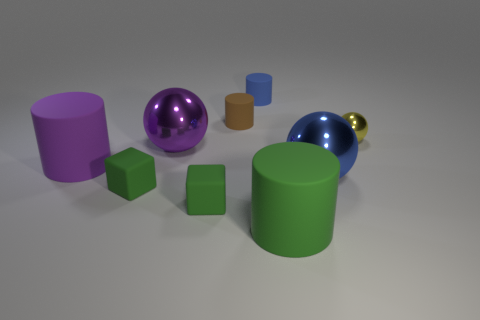What size is the brown matte object?
Your answer should be very brief. Small. What number of green objects are spheres or tiny cylinders?
Your response must be concise. 0. What number of blue shiny objects are the same shape as the yellow object?
Your answer should be compact. 1. What number of green blocks have the same size as the purple metallic ball?
Make the answer very short. 0. What is the material of the green object that is the same shape as the purple matte object?
Ensure brevity in your answer.  Rubber. There is a large cylinder that is left of the big green matte object; what color is it?
Provide a succinct answer. Purple. Are there more large green cylinders on the right side of the large green cylinder than large purple rubber things?
Offer a terse response. No. What is the color of the tiny sphere?
Your answer should be compact. Yellow. What is the shape of the blue thing that is behind the small yellow metal thing behind the purple object on the right side of the large purple cylinder?
Give a very brief answer. Cylinder. The cylinder that is behind the purple shiny sphere and in front of the blue rubber cylinder is made of what material?
Your response must be concise. Rubber. 